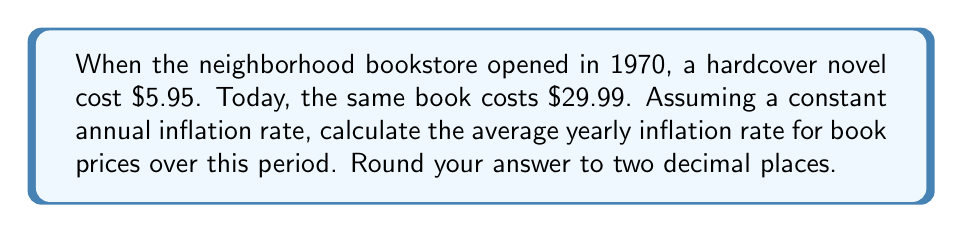Can you answer this question? To solve this problem, we'll use the compound interest formula, as inflation compounds annually:

$$ FV = PV(1 + r)^n $$

Where:
FV = Future Value (current price)
PV = Present Value (original price)
r = Annual inflation rate (what we're solving for)
n = Number of years

1. Let's identify our known values:
   FV = $29.99
   PV = $5.95
   n = 2023 - 1970 = 53 years

2. Plug these into the formula:
   $$ 29.99 = 5.95(1 + r)^{53} $$

3. Divide both sides by 5.95:
   $$ \frac{29.99}{5.95} = (1 + r)^{53} $$

4. Take the 53rd root of both sides:
   $$ \sqrt[53]{\frac{29.99}{5.95}} = 1 + r $$

5. Subtract 1 from both sides:
   $$ \sqrt[53]{\frac{29.99}{5.95}} - 1 = r $$

6. Calculate:
   $$ r = \sqrt[53]{5.0403361} - 1 $$
   $$ r = 1.0325947 - 1 $$
   $$ r = 0.0325947 $$

7. Convert to a percentage and round to two decimal places:
   $$ r = 3.26\% $$
Answer: 3.26% 